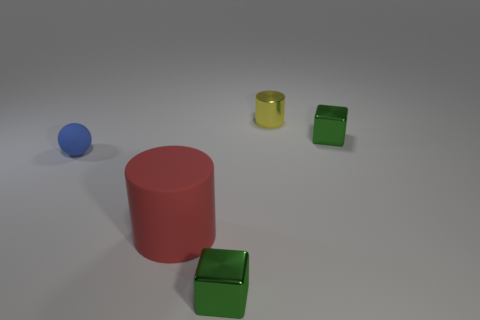Add 3 small cyan metal cylinders. How many objects exist? 8 Subtract all blocks. How many objects are left? 3 Subtract all big red rubber cylinders. Subtract all small yellow cylinders. How many objects are left? 3 Add 4 green metallic objects. How many green metallic objects are left? 6 Add 4 green metal objects. How many green metal objects exist? 6 Subtract 0 gray balls. How many objects are left? 5 